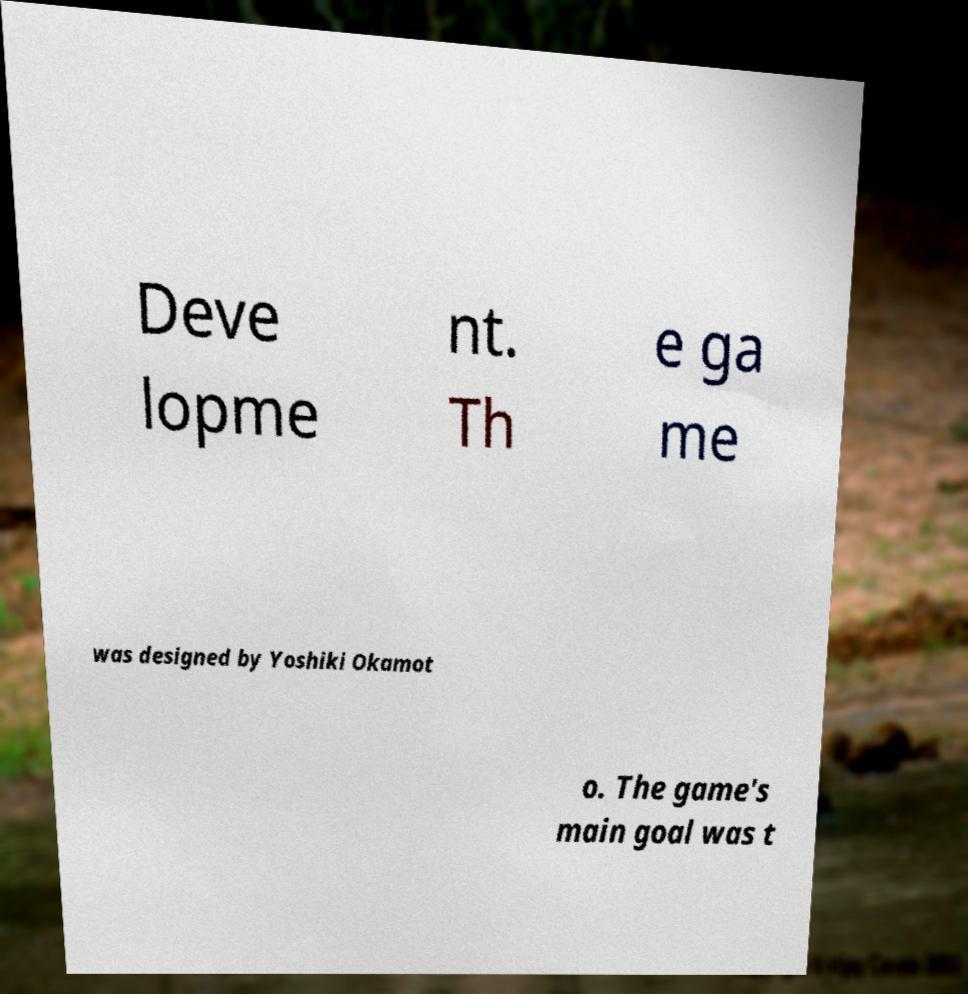There's text embedded in this image that I need extracted. Can you transcribe it verbatim? Deve lopme nt. Th e ga me was designed by Yoshiki Okamot o. The game's main goal was t 